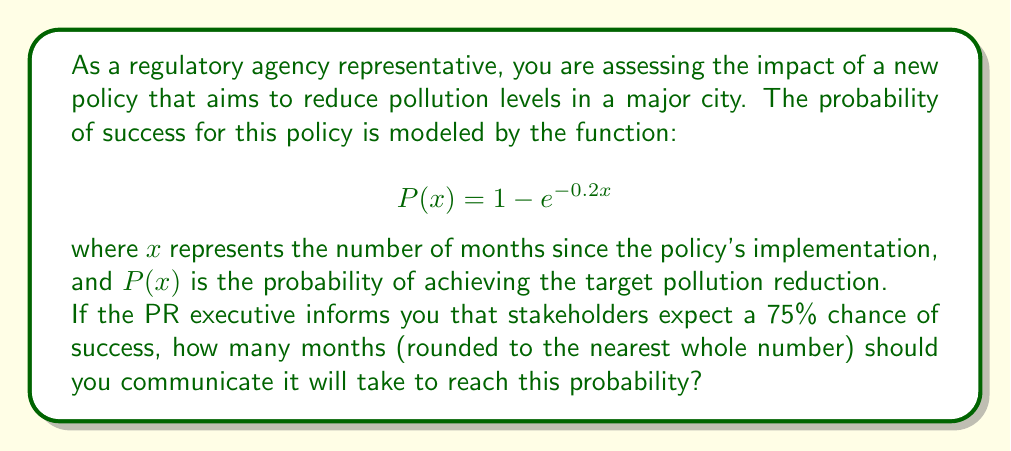Teach me how to tackle this problem. To solve this problem, we need to follow these steps:

1) We are given the probability function:
   $$P(x) = 1 - e^{-0.2x}$$

2) We want to find $x$ when $P(x) = 0.75$ (75% chance of success)

3) Let's set up the equation:
   $$0.75 = 1 - e^{-0.2x}$$

4) Subtract both sides from 1:
   $$0.25 = e^{-0.2x}$$

5) Take the natural log of both sides:
   $$\ln(0.25) = -0.2x$$

6) Solve for $x$:
   $$x = \frac{\ln(0.25)}{-0.2}$$

7) Calculate:
   $$x = \frac{-1.3862943611198906}{-0.2} \approx 6.93147$$

8) Round to the nearest whole number:
   $$x \approx 7$$

Therefore, it will take approximately 7 months to reach a 75% probability of success.
Answer: 7 months 